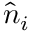<formula> <loc_0><loc_0><loc_500><loc_500>\hat { n } _ { i }</formula> 